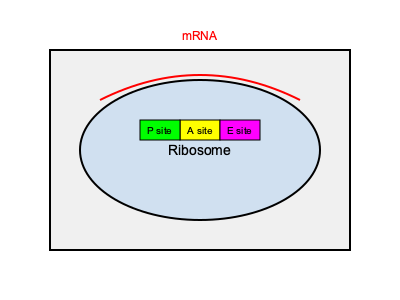In the context of protein synthesis, what is the function of the P site in the ribosome, and how does it contribute to the process of translating mRNA into a polypeptide chain? To understand the function of the P site in protein synthesis, let's break down the process:

1. The ribosome has three main sites: A (Aminoacyl), P (Peptidyl), and E (Exit).

2. The P site is where the growing polypeptide chain is held during protein synthesis.

3. Process of translation:
   a. Initiation: The first tRNA with the start codon (usually AUG) binds to the P site.
   b. Elongation:
      - A new tRNA enters the A site, matching the next codon on the mRNA.
      - A peptide bond forms between the amino acid in the P site and the one in the A site.
      - The ribosome shifts, moving the growing peptide chain from the A site to the P site.
   c. This process repeats, with the P site always holding the growing polypeptide chain.

4. The P site ensures that:
   - The growing peptide chain remains attached to the ribosome during synthesis.
   - It positions the peptide for the formation of new peptide bonds with incoming amino acids.

5. The P site works in coordination with the A and E sites to facilitate the stepwise addition of amino acids to the growing polypeptide chain.

In summary, the P site is crucial for holding and positioning the growing polypeptide chain during protein synthesis, enabling the sequential addition of amino acids as directed by the mRNA sequence.
Answer: The P site holds and positions the growing polypeptide chain during protein synthesis. 